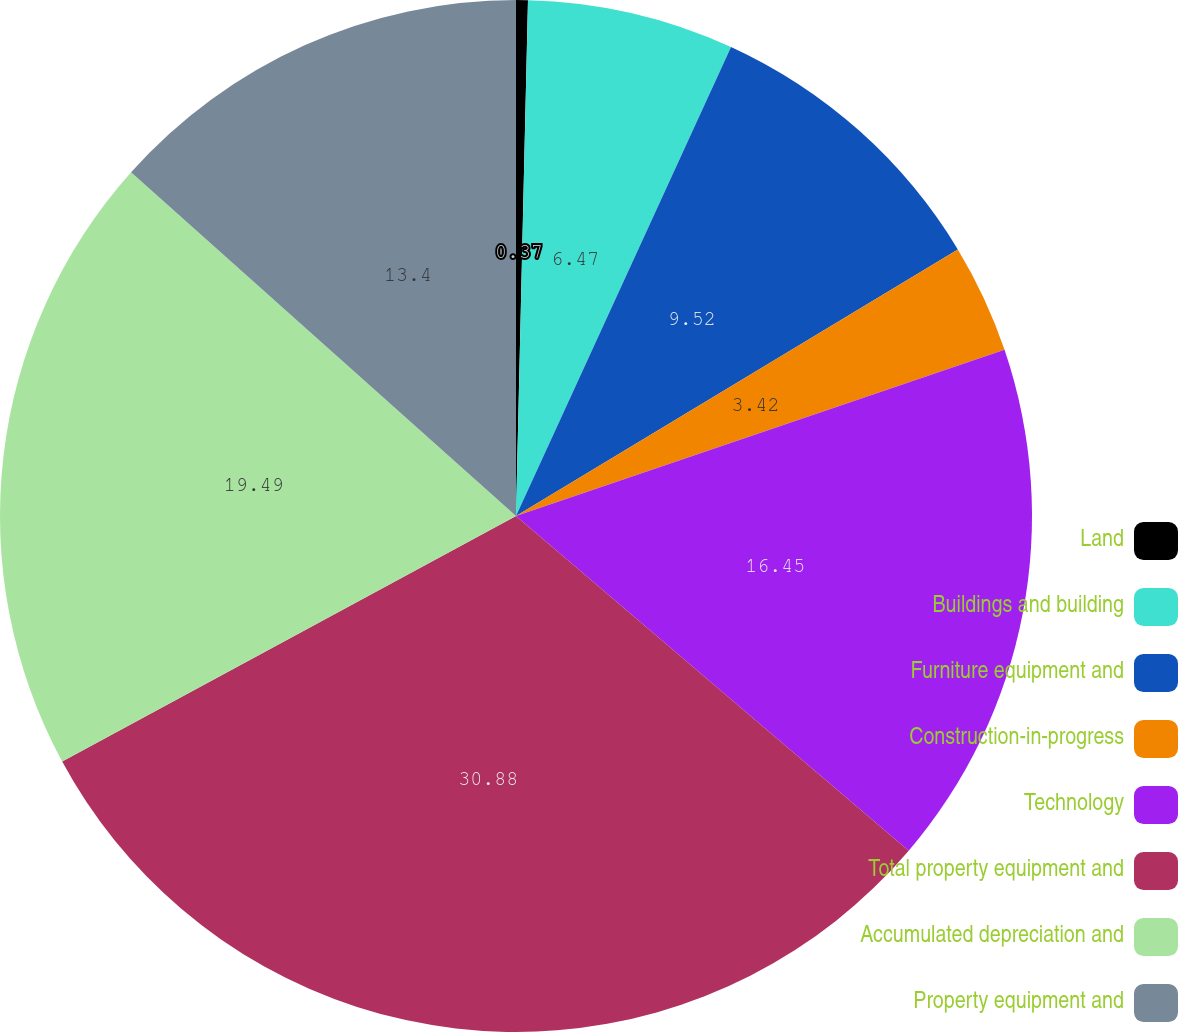Convert chart to OTSL. <chart><loc_0><loc_0><loc_500><loc_500><pie_chart><fcel>Land<fcel>Buildings and building<fcel>Furniture equipment and<fcel>Construction-in-progress<fcel>Technology<fcel>Total property equipment and<fcel>Accumulated depreciation and<fcel>Property equipment and<nl><fcel>0.37%<fcel>6.47%<fcel>9.52%<fcel>3.42%<fcel>16.45%<fcel>30.87%<fcel>19.49%<fcel>13.4%<nl></chart> 